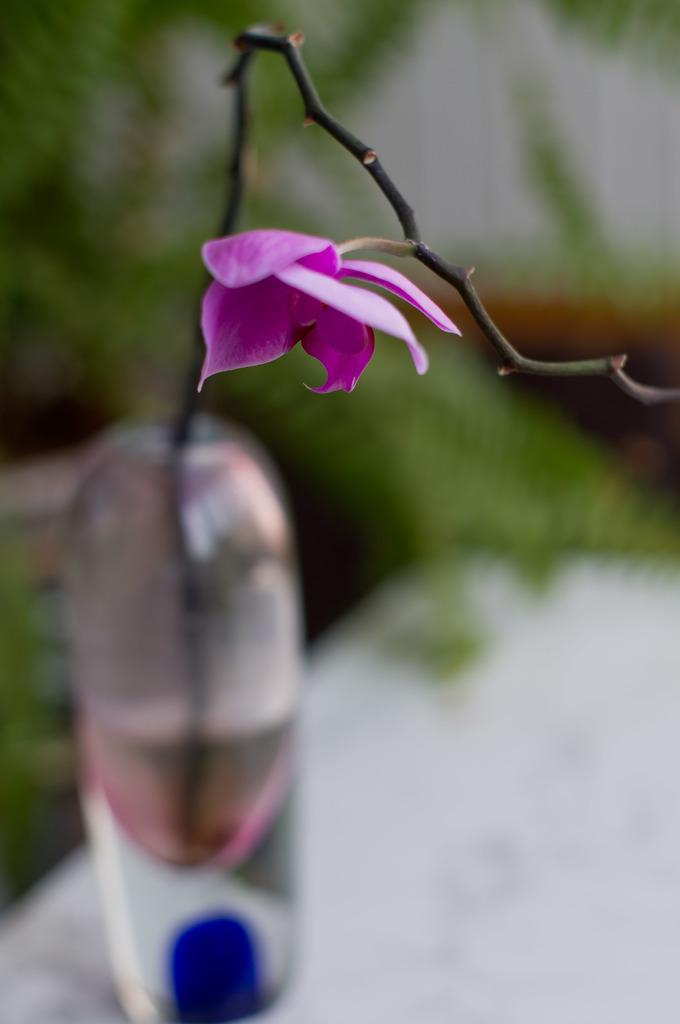What type of flower is on the stick in the image? There is a pink flower on a stick in the image. How is the stick with the flower positioned? The stick with the flower is in a bottle. What can be seen in the background of the image? There is a wall and plants visible in the background. Where is the nest of the fish in the image? There is no nest or fish present in the image. What type of zephyr can be seen blowing through the plants in the background? There is no zephyr visible in the image; it is a still image with no movement or wind. 